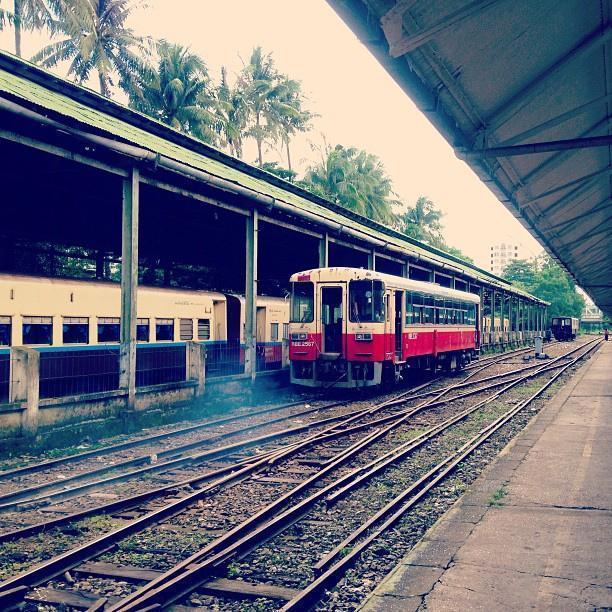Which word best describes this train station?
Choose the correct response and explain in the format: 'Answer: answer
Rationale: rationale.'
Options: New, alive, decrepit, bustling. Answer: decrepit.
Rationale: The station is mostly empty and does not seem to be in good shape. 